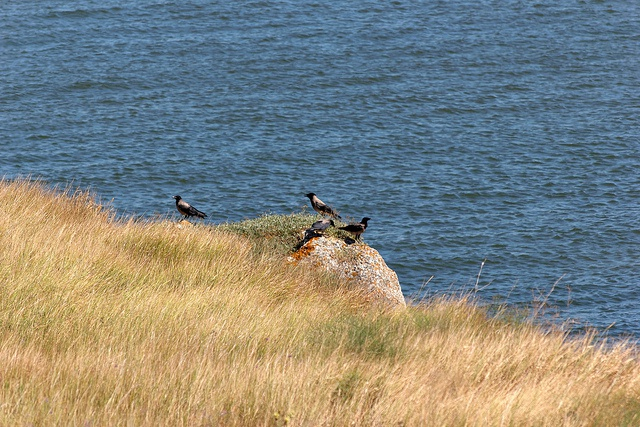Describe the objects in this image and their specific colors. I can see bird in gray, black, and maroon tones, bird in gray, black, maroon, and darkgray tones, bird in gray, black, and maroon tones, and bird in gray, black, olive, and darkgray tones in this image. 